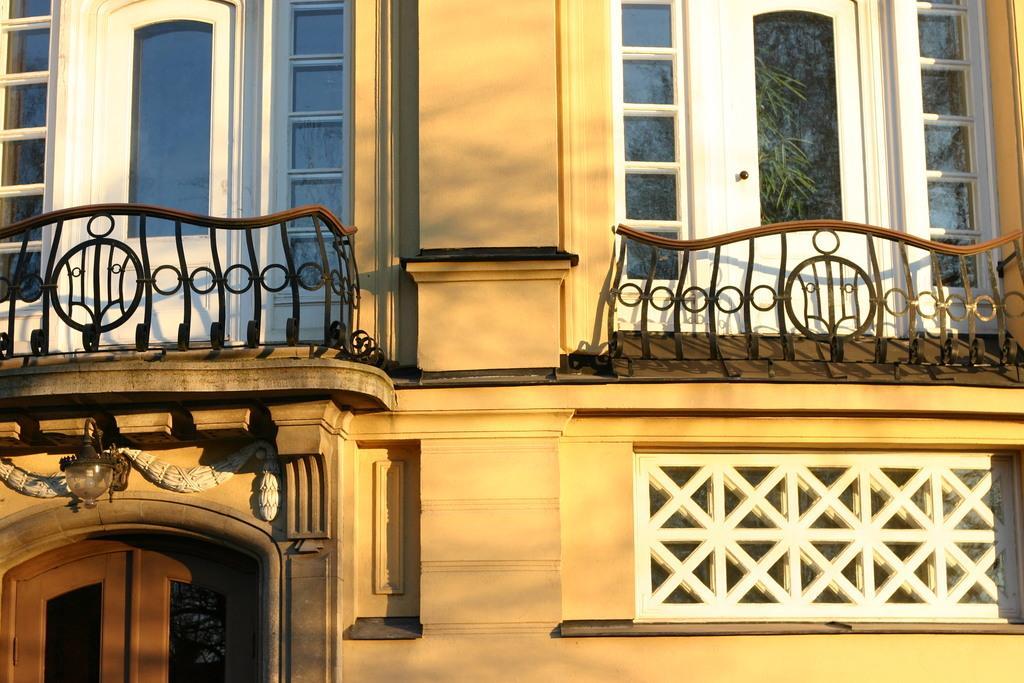Could you give a brief overview of what you see in this image? In this image we can see one cream color building with two balconies, two white doors with glasses, one main brown color door and one light attached to the wall above the door. 